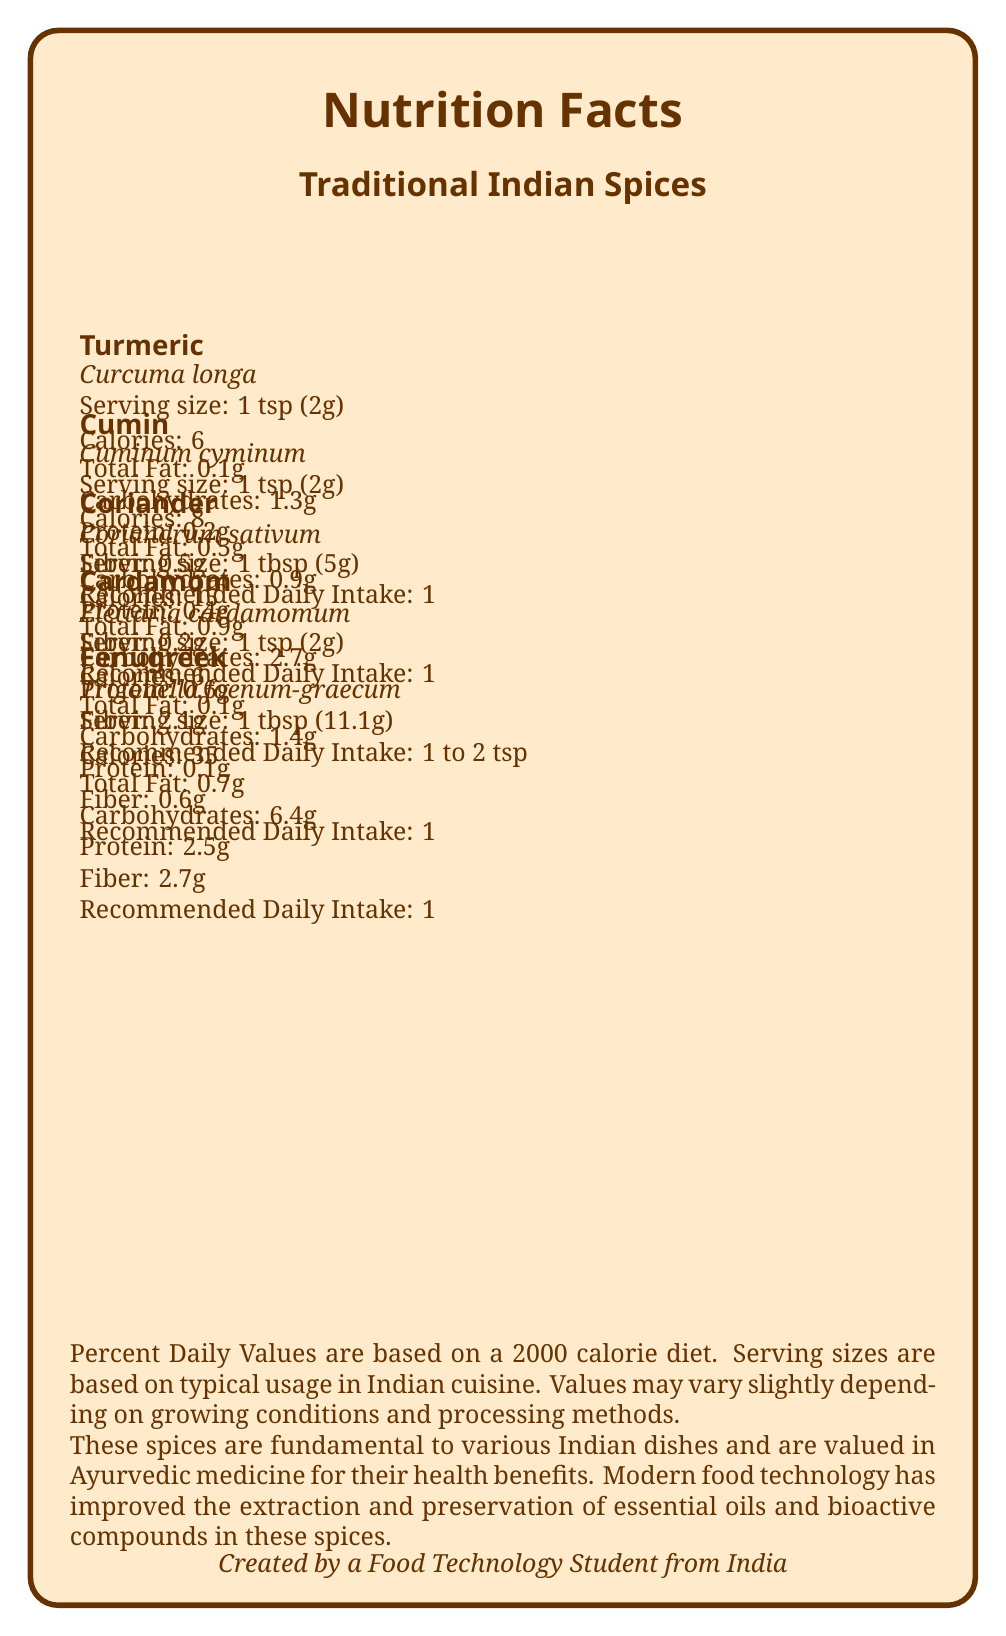what is the recommended daily intake of turmeric? The document states that the recommended daily intake for turmeric is 1/4 to 1 teaspoon.
Answer: 1/4 to 1 teaspoon how many calories are in a serving of cumin? According to the document, 1 teaspoon (2g) of cumin contains 8 calories.
Answer: 8 which spice has the highest amount of fiber per serving? The document shows that fenugreek has 2.7g of fiber per serving, which is the highest among the listed spices.
Answer: Fenugreek what is the scientific name for coriander? The scientific name of coriander as mentioned in the document is Coriandrum sativum.
Answer: Coriandrum sativum how much protein is in a serving of cardamom? The document states that 1 teaspoon (2g) of cardamom contains 0.1g of protein.
Answer: 0.1g which spice has the highest iron content per serving? A. Turmeric B. Cumin C. Coriander D. Fenugreek The document indicates that fenugreek has 3.7g of iron per serving, which is higher than the other spices listed.
Answer: D. Fenugreek what is the recommended daily intake of fenugreek? A. 1/4 to 1 teaspoon B. 1/2 to 1 teaspoon C. 1 to 2 teaspoons D. 1/8 to 1/4 teaspoon The recommended daily intake for fenugreek is 1/2 to 1 teaspoon as per the document.
Answer: B. 1/2 to 1 teaspoon is the daily value of nutrients based on a 2000 calorie diet? The daily value percentages are based on a 2000 calorie diet according to the document.
Answer: Yes describe the main idea of the document. The document includes specific nutritional data for spices like turmeric, cumin, coriander, cardamom, and fenugreek. It elaborates on their use in Indian cuisine, their health benefits according to Ayurveda, and discusses advancements in food technology relevant to these spices.
Answer: The document provides nutritional facts about traditional Indian spices, including their calorie content, macronutrients, and recommended daily intakes. It also offers contextual information about the use of these spices in Indian cuisine and their importance in Ayurvedic medicine. The document highlights modern food technology's role in improving spice preservation and quality. what modern food technology improvement is mentioned in the document? The document states that modern food technology has improved the extraction and preservation of essential oils and bioactive compounds in these spices.
Answer: Improved extraction and preservation of essential oils and bioactive compounds what are the typical serving sizes based on? The document indicates that serving sizes are based on typical usage in Indian cuisine.
Answer: Typical usage in Indian cuisine which spice has the lowest total fat content per serving? The document shows that turmeric has only 0.1g of total fat per serving, which is the lowest among the listed spices.
Answer: Turmeric what is the main application of spices in relation to Indian cuisine? The document highlights that these spices are fundamental to various Indian dishes, including curries, dal, and biryani.
Answer: Fundamental to various Indian dishes such as curries, dal, and biryani which spices have manganese content mentioned in their nutritional profile? The document lists manganese content for turmeric (0.2g), cumin (0.1g), cardamom (0.2g), and fenugreek (0.1g).
Answer: Turmeric, cumin, cardamom, fenugreek what is the total carbohydrate content in a serving of coriander? According to the document, 1 tablespoon (5g) of coriander contains 2.7g of carbohydrates.
Answer: 2.7g what role do advanced analytical techniques play in spice production? The document states that advanced analytical techniques are used to ensure the purity and potency of spices in commercial production.
Answer: Ensure the purity and potency of spices in commercial production how much calcium is in a serving of cumin? The document specifies that 1 teaspoon (2g) of cumin contains 22mg of calcium.
Answer: 22mg in what context is ayurveda mentioned in the document? The document mentions that these spices are valued in Ayurvedic medicine for their health benefits.
Answer: Many of these spices are valued in Ayurvedic medicine for their health benefits 